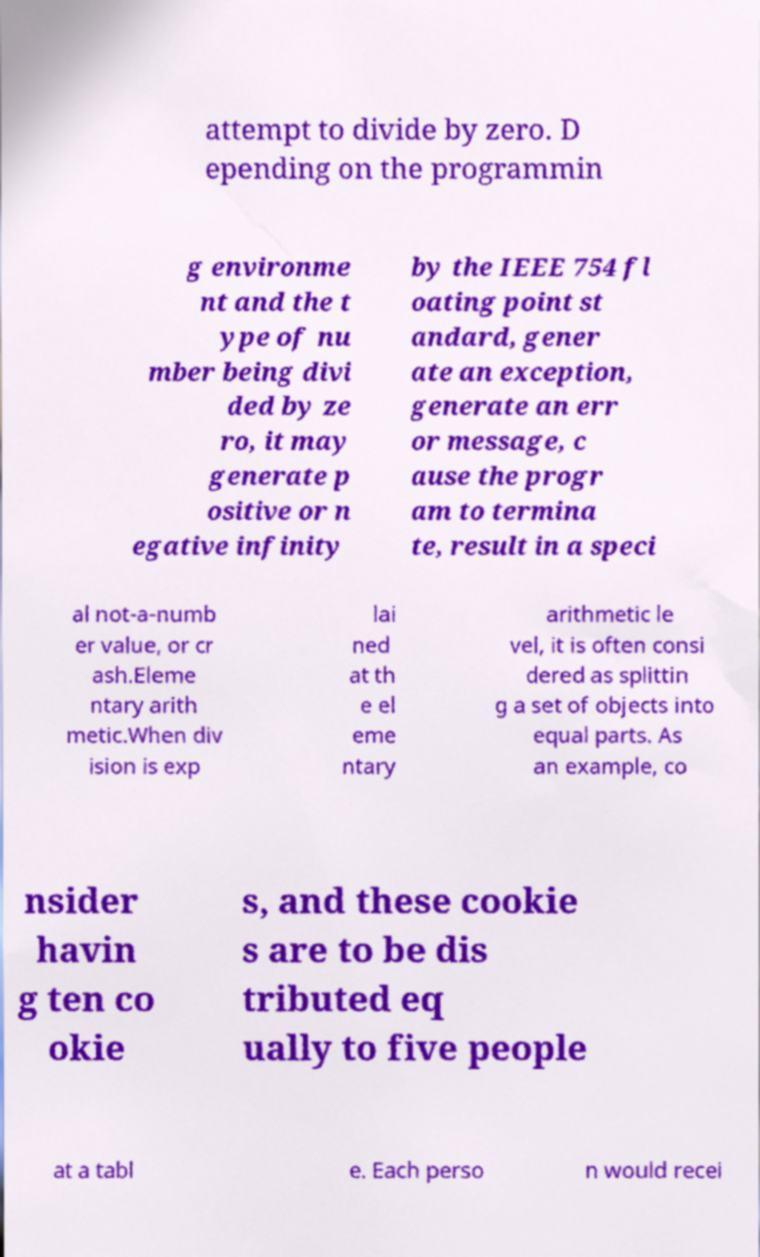Please identify and transcribe the text found in this image. attempt to divide by zero. D epending on the programmin g environme nt and the t ype of nu mber being divi ded by ze ro, it may generate p ositive or n egative infinity by the IEEE 754 fl oating point st andard, gener ate an exception, generate an err or message, c ause the progr am to termina te, result in a speci al not-a-numb er value, or cr ash.Eleme ntary arith metic.When div ision is exp lai ned at th e el eme ntary arithmetic le vel, it is often consi dered as splittin g a set of objects into equal parts. As an example, co nsider havin g ten co okie s, and these cookie s are to be dis tributed eq ually to five people at a tabl e. Each perso n would recei 